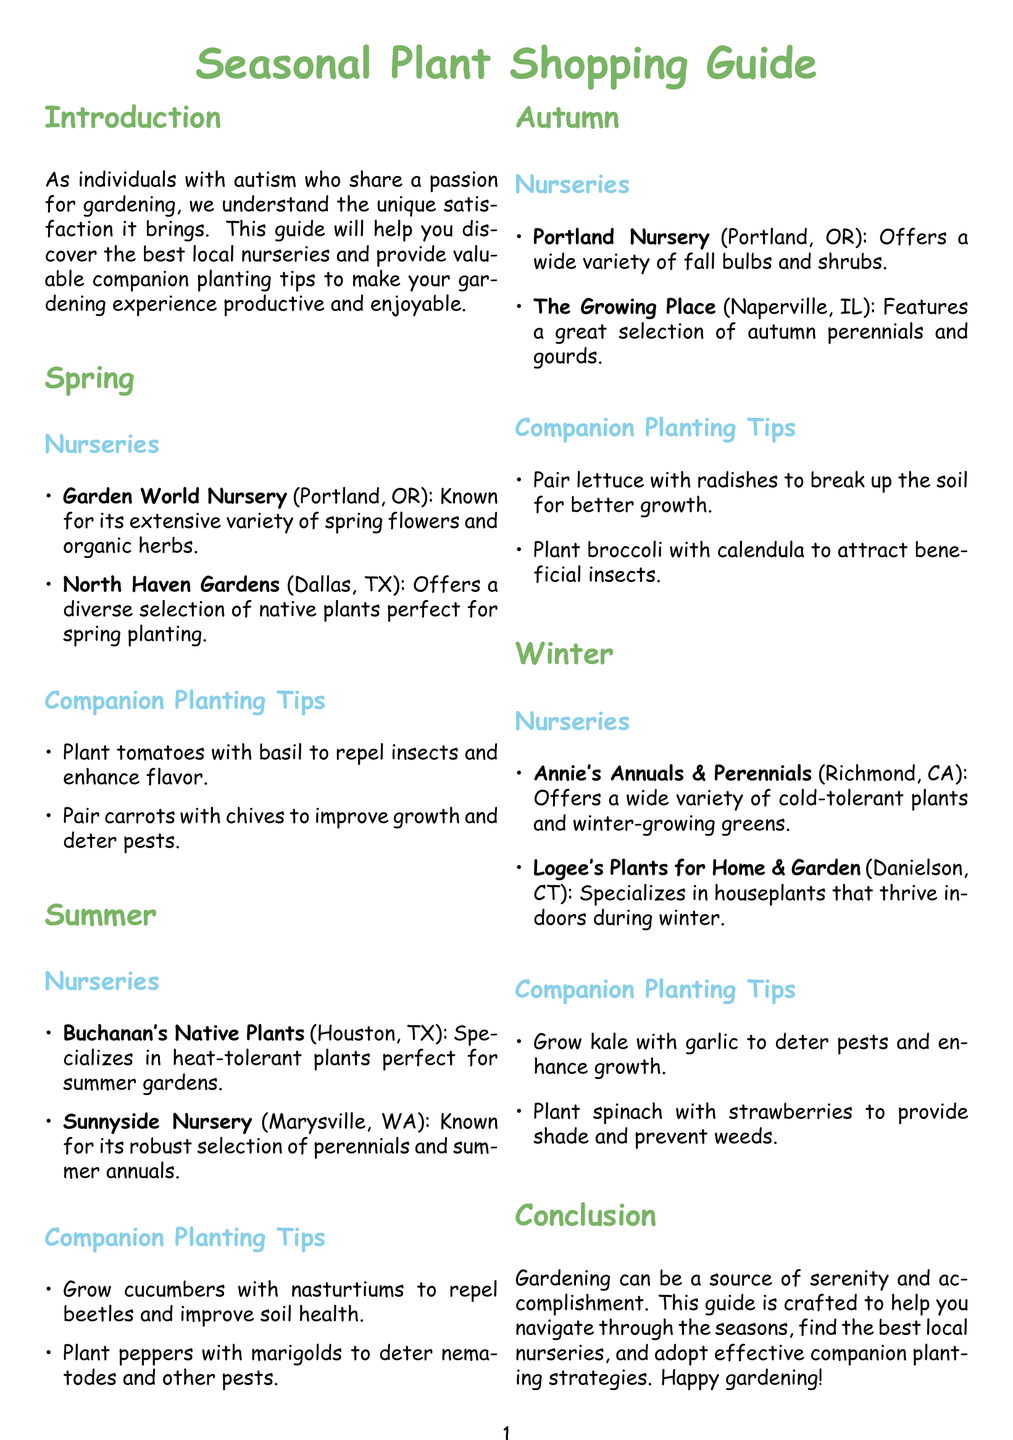What is the title of the guide? The title of the guide is prominently displayed at the top of the document.
Answer: Seasonal Plant Shopping Guide Which nursery is located in Portland, OR? The document lists two nurseries in Portland, OR, under the Spring section.
Answer: Garden World Nursery What companion plant should be paired with cucumbers? The document mentions a specific companion plant for cucumbers under the Summer section.
Answer: Nasturtiums How many seasons are covered in the guide? The document explicitly lists four seasons in the structured layout.
Answer: Four Which plant can be grown with garlic? The Autumn section of the document specifies a companion plant that pairs well with garlic.
Answer: Kale What type of plants does Logee's specialize in? The document describes the type of plants offered by Logee's in the Winter section.
Answer: Houseplants What is the main goal of this guide? The conclusion summarizes the primary purpose of the guide as stated in the document.
Answer: Help navigate through the seasons Which nursery is known for heat-tolerant plants? This information is found in the Summer section of the document under nurseries.
Answer: Buchanan's Native Plants 